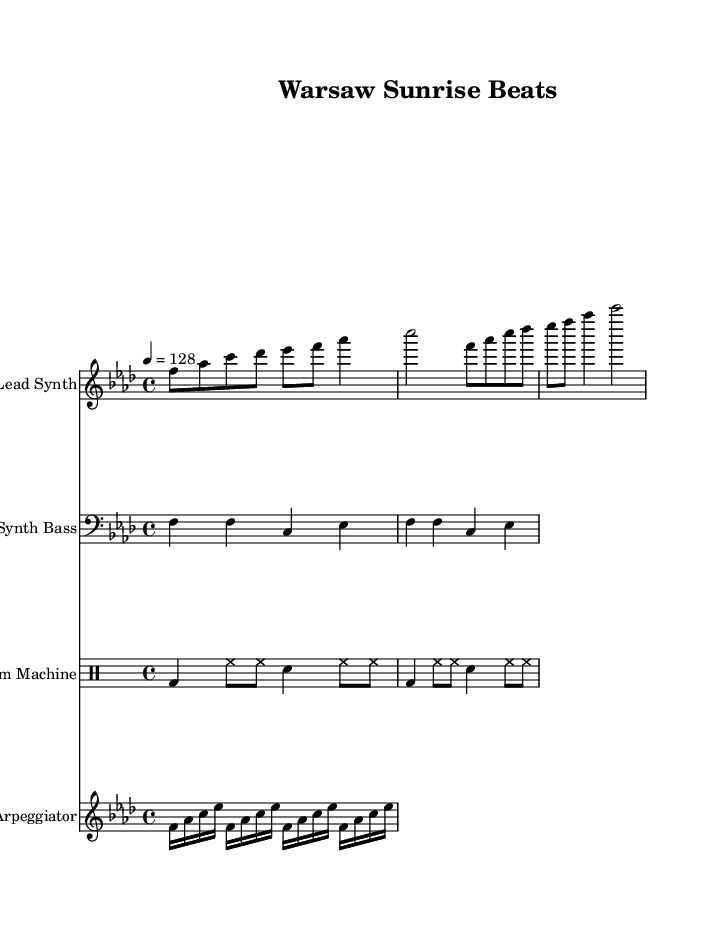What is the key signature of this music? The key signature is determined by the number of sharps or flats indicated at the beginning of the score. In this case, the score has four flats, which indicates that the key is F minor.
Answer: F minor What is the time signature of the piece? The time signature is located at the beginning of the score, represented by numbers indicating the number of beats in a measure. Here, the time signature is 4/4, meaning there are four beats in each measure.
Answer: 4/4 What is the tempo marking of this piece? The tempo marking is provided at the beginning of the score with the indication of beats per minute. This score shows a tempo of 128 beats per minute, which signifies a fast-paced rhythm.
Answer: 128 Which instrument has the line that begins with "f8 aes c des ees"? To identify the instrument, look at the labeled staves above the musical notes. The line beginning with "f8 aes c des ees" is in the "Lead Synth" staff, which is noted at the left.
Answer: Lead Synth How many measures are in the "Synth Bass" part? To find the number of measures in the Synth Bass part, count the number of bar lines in the musical staff under that section. There are four measures in total for the Synth Bass part.
Answer: 4 What type of drum pattern is employed in this music? The drum section uses a combination of bass drum and snare hits, along with hi-hat notes. The specific pattern alternates between these elements and is characteristic of rhythmic techno beats that support dance music.
Answer: Techno drum pattern What is the function of the arpeggiator in this piece? The arpeggiator section consists of continuously rising and falling notes, which create a flowing and energetic effect. This element supports the overall dynamic feel of dance music by providing a rhythmic and harmonic backdrop.
Answer: Harmonic backdrop 